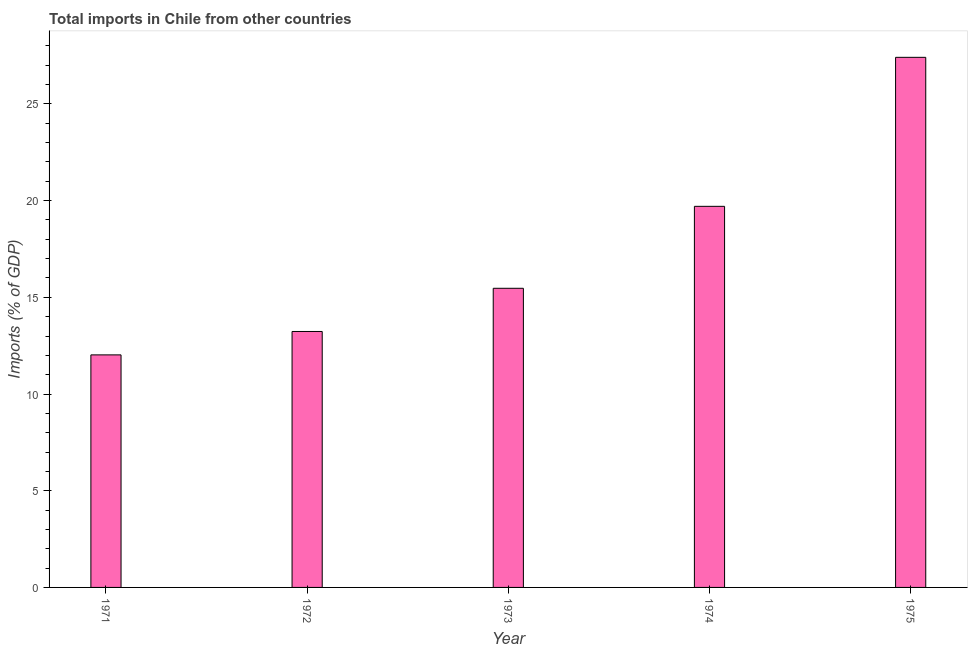Does the graph contain grids?
Offer a very short reply. No. What is the title of the graph?
Provide a short and direct response. Total imports in Chile from other countries. What is the label or title of the Y-axis?
Keep it short and to the point. Imports (% of GDP). What is the total imports in 1972?
Your answer should be compact. 13.23. Across all years, what is the maximum total imports?
Offer a very short reply. 27.41. Across all years, what is the minimum total imports?
Provide a succinct answer. 12.02. In which year was the total imports maximum?
Your answer should be very brief. 1975. In which year was the total imports minimum?
Offer a very short reply. 1971. What is the sum of the total imports?
Your response must be concise. 87.84. What is the difference between the total imports in 1972 and 1975?
Your answer should be very brief. -14.18. What is the average total imports per year?
Provide a succinct answer. 17.57. What is the median total imports?
Keep it short and to the point. 15.47. Do a majority of the years between 1974 and 1973 (inclusive) have total imports greater than 17 %?
Make the answer very short. No. What is the ratio of the total imports in 1971 to that in 1973?
Your answer should be very brief. 0.78. Is the total imports in 1971 less than that in 1975?
Provide a succinct answer. Yes. Is the difference between the total imports in 1971 and 1975 greater than the difference between any two years?
Keep it short and to the point. Yes. What is the difference between the highest and the second highest total imports?
Your answer should be compact. 7.71. What is the difference between the highest and the lowest total imports?
Offer a very short reply. 15.39. In how many years, is the total imports greater than the average total imports taken over all years?
Give a very brief answer. 2. How many years are there in the graph?
Make the answer very short. 5. What is the difference between two consecutive major ticks on the Y-axis?
Your answer should be compact. 5. Are the values on the major ticks of Y-axis written in scientific E-notation?
Make the answer very short. No. What is the Imports (% of GDP) of 1971?
Offer a terse response. 12.02. What is the Imports (% of GDP) of 1972?
Your answer should be very brief. 13.23. What is the Imports (% of GDP) in 1973?
Your answer should be very brief. 15.47. What is the Imports (% of GDP) in 1974?
Ensure brevity in your answer.  19.71. What is the Imports (% of GDP) in 1975?
Offer a very short reply. 27.41. What is the difference between the Imports (% of GDP) in 1971 and 1972?
Provide a succinct answer. -1.21. What is the difference between the Imports (% of GDP) in 1971 and 1973?
Keep it short and to the point. -3.44. What is the difference between the Imports (% of GDP) in 1971 and 1974?
Give a very brief answer. -7.68. What is the difference between the Imports (% of GDP) in 1971 and 1975?
Your response must be concise. -15.39. What is the difference between the Imports (% of GDP) in 1972 and 1973?
Keep it short and to the point. -2.23. What is the difference between the Imports (% of GDP) in 1972 and 1974?
Your answer should be compact. -6.47. What is the difference between the Imports (% of GDP) in 1972 and 1975?
Make the answer very short. -14.18. What is the difference between the Imports (% of GDP) in 1973 and 1974?
Your answer should be very brief. -4.24. What is the difference between the Imports (% of GDP) in 1973 and 1975?
Your answer should be very brief. -11.94. What is the difference between the Imports (% of GDP) in 1974 and 1975?
Your answer should be compact. -7.7. What is the ratio of the Imports (% of GDP) in 1971 to that in 1972?
Your answer should be compact. 0.91. What is the ratio of the Imports (% of GDP) in 1971 to that in 1973?
Ensure brevity in your answer.  0.78. What is the ratio of the Imports (% of GDP) in 1971 to that in 1974?
Give a very brief answer. 0.61. What is the ratio of the Imports (% of GDP) in 1971 to that in 1975?
Provide a short and direct response. 0.44. What is the ratio of the Imports (% of GDP) in 1972 to that in 1973?
Provide a succinct answer. 0.86. What is the ratio of the Imports (% of GDP) in 1972 to that in 1974?
Keep it short and to the point. 0.67. What is the ratio of the Imports (% of GDP) in 1972 to that in 1975?
Offer a terse response. 0.48. What is the ratio of the Imports (% of GDP) in 1973 to that in 1974?
Keep it short and to the point. 0.79. What is the ratio of the Imports (% of GDP) in 1973 to that in 1975?
Make the answer very short. 0.56. What is the ratio of the Imports (% of GDP) in 1974 to that in 1975?
Your answer should be very brief. 0.72. 